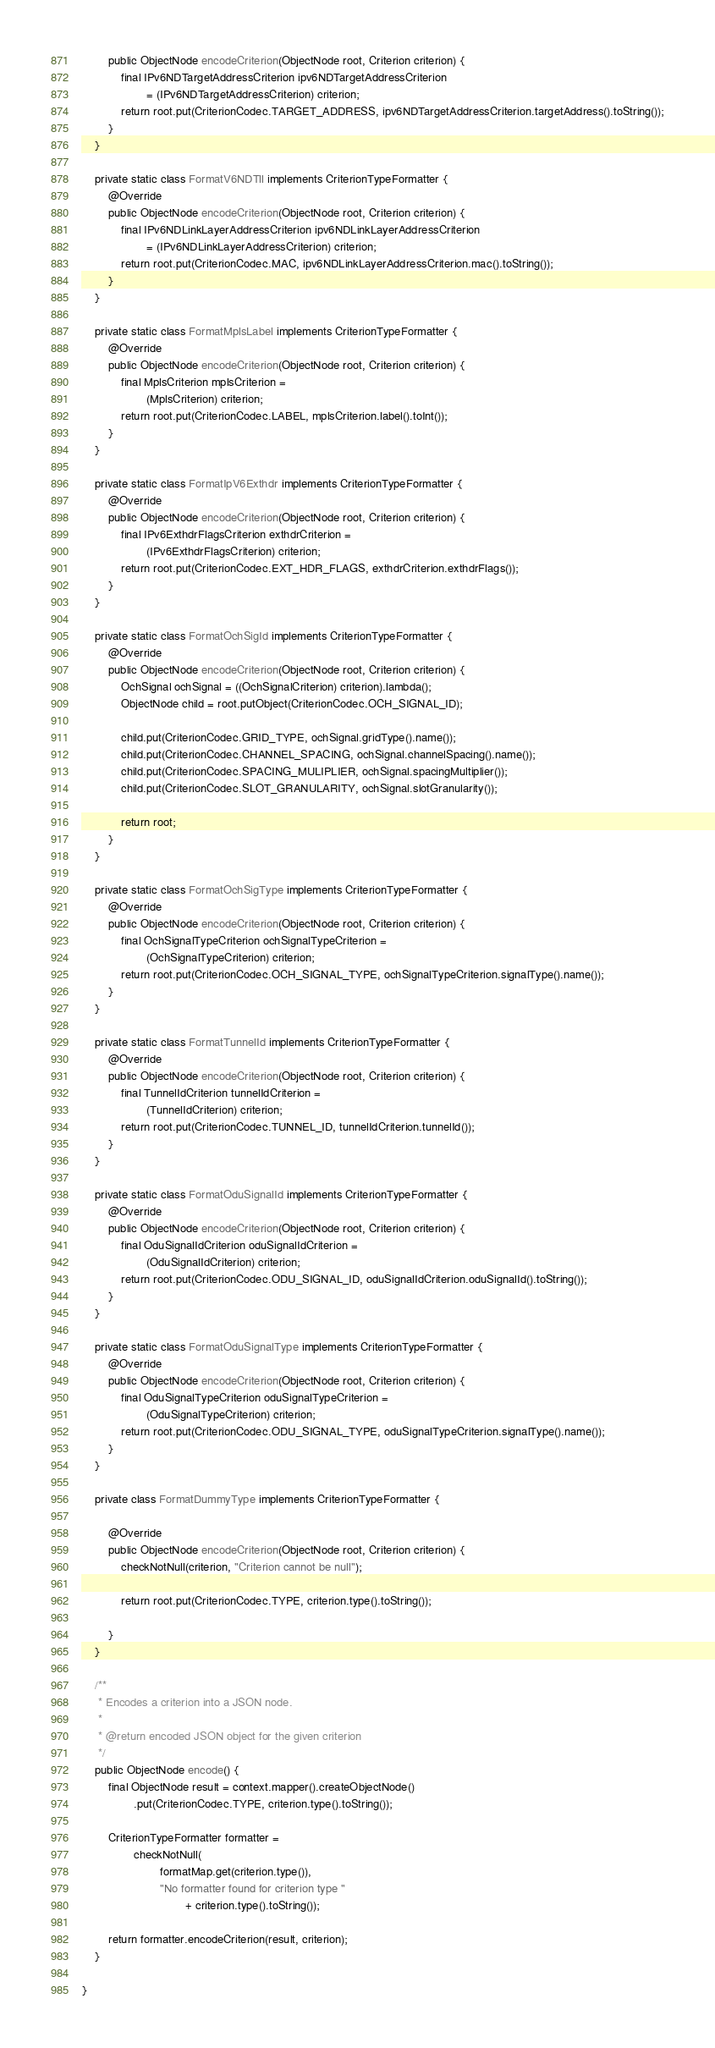<code> <loc_0><loc_0><loc_500><loc_500><_Java_>        public ObjectNode encodeCriterion(ObjectNode root, Criterion criterion) {
            final IPv6NDTargetAddressCriterion ipv6NDTargetAddressCriterion
                    = (IPv6NDTargetAddressCriterion) criterion;
            return root.put(CriterionCodec.TARGET_ADDRESS, ipv6NDTargetAddressCriterion.targetAddress().toString());
        }
    }

    private static class FormatV6NDTll implements CriterionTypeFormatter {
        @Override
        public ObjectNode encodeCriterion(ObjectNode root, Criterion criterion) {
            final IPv6NDLinkLayerAddressCriterion ipv6NDLinkLayerAddressCriterion
                    = (IPv6NDLinkLayerAddressCriterion) criterion;
            return root.put(CriterionCodec.MAC, ipv6NDLinkLayerAddressCriterion.mac().toString());
        }
    }

    private static class FormatMplsLabel implements CriterionTypeFormatter {
        @Override
        public ObjectNode encodeCriterion(ObjectNode root, Criterion criterion) {
            final MplsCriterion mplsCriterion =
                    (MplsCriterion) criterion;
            return root.put(CriterionCodec.LABEL, mplsCriterion.label().toInt());
        }
    }

    private static class FormatIpV6Exthdr implements CriterionTypeFormatter {
        @Override
        public ObjectNode encodeCriterion(ObjectNode root, Criterion criterion) {
            final IPv6ExthdrFlagsCriterion exthdrCriterion =
                    (IPv6ExthdrFlagsCriterion) criterion;
            return root.put(CriterionCodec.EXT_HDR_FLAGS, exthdrCriterion.exthdrFlags());
        }
    }

    private static class FormatOchSigId implements CriterionTypeFormatter {
        @Override
        public ObjectNode encodeCriterion(ObjectNode root, Criterion criterion) {
            OchSignal ochSignal = ((OchSignalCriterion) criterion).lambda();
            ObjectNode child = root.putObject(CriterionCodec.OCH_SIGNAL_ID);

            child.put(CriterionCodec.GRID_TYPE, ochSignal.gridType().name());
            child.put(CriterionCodec.CHANNEL_SPACING, ochSignal.channelSpacing().name());
            child.put(CriterionCodec.SPACING_MULIPLIER, ochSignal.spacingMultiplier());
            child.put(CriterionCodec.SLOT_GRANULARITY, ochSignal.slotGranularity());

            return root;
        }
    }

    private static class FormatOchSigType implements CriterionTypeFormatter {
        @Override
        public ObjectNode encodeCriterion(ObjectNode root, Criterion criterion) {
            final OchSignalTypeCriterion ochSignalTypeCriterion =
                    (OchSignalTypeCriterion) criterion;
            return root.put(CriterionCodec.OCH_SIGNAL_TYPE, ochSignalTypeCriterion.signalType().name());
        }
    }

    private static class FormatTunnelId implements CriterionTypeFormatter {
        @Override
        public ObjectNode encodeCriterion(ObjectNode root, Criterion criterion) {
            final TunnelIdCriterion tunnelIdCriterion =
                    (TunnelIdCriterion) criterion;
            return root.put(CriterionCodec.TUNNEL_ID, tunnelIdCriterion.tunnelId());
        }
    }

    private static class FormatOduSignalId implements CriterionTypeFormatter {
        @Override
        public ObjectNode encodeCriterion(ObjectNode root, Criterion criterion) {
            final OduSignalIdCriterion oduSignalIdCriterion =
                    (OduSignalIdCriterion) criterion;
            return root.put(CriterionCodec.ODU_SIGNAL_ID, oduSignalIdCriterion.oduSignalId().toString());
        }
    }

    private static class FormatOduSignalType implements CriterionTypeFormatter {
        @Override
        public ObjectNode encodeCriterion(ObjectNode root, Criterion criterion) {
            final OduSignalTypeCriterion oduSignalTypeCriterion =
                    (OduSignalTypeCriterion) criterion;
            return root.put(CriterionCodec.ODU_SIGNAL_TYPE, oduSignalTypeCriterion.signalType().name());
        }
    }

    private class FormatDummyType implements CriterionTypeFormatter {

        @Override
        public ObjectNode encodeCriterion(ObjectNode root, Criterion criterion) {
            checkNotNull(criterion, "Criterion cannot be null");

            return root.put(CriterionCodec.TYPE, criterion.type().toString());

        }
    }

    /**
     * Encodes a criterion into a JSON node.
     *
     * @return encoded JSON object for the given criterion
     */
    public ObjectNode encode() {
        final ObjectNode result = context.mapper().createObjectNode()
                .put(CriterionCodec.TYPE, criterion.type().toString());

        CriterionTypeFormatter formatter =
                checkNotNull(
                        formatMap.get(criterion.type()),
                        "No formatter found for criterion type "
                                + criterion.type().toString());

        return formatter.encodeCriterion(result, criterion);
    }

}
</code> 